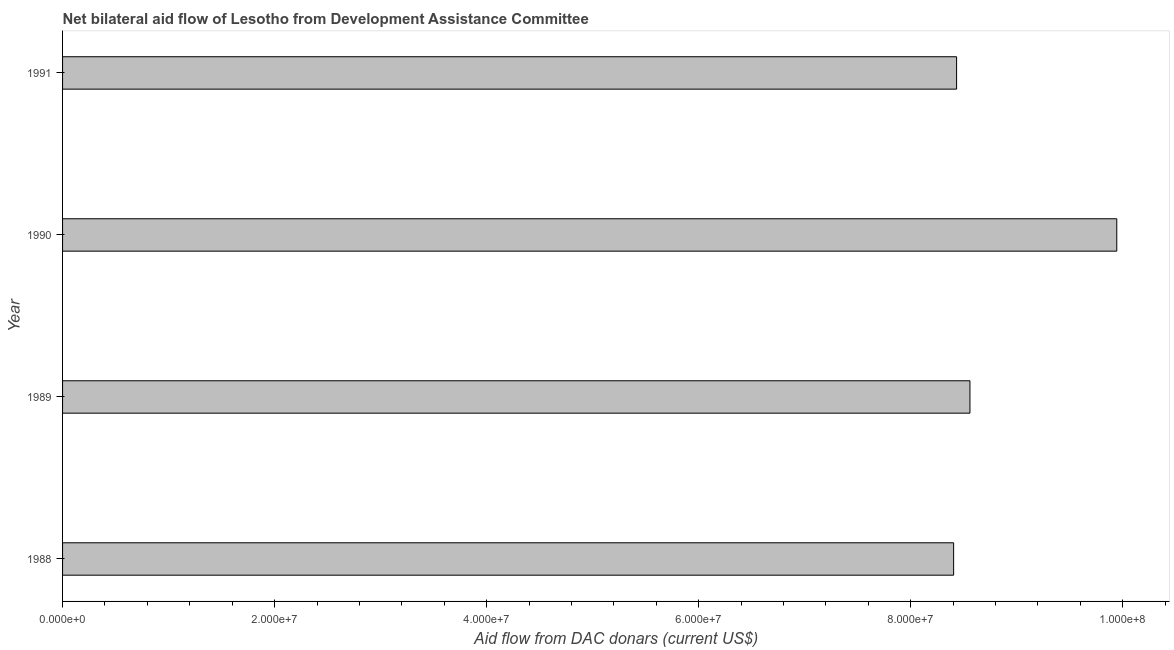Does the graph contain grids?
Your response must be concise. No. What is the title of the graph?
Your answer should be very brief. Net bilateral aid flow of Lesotho from Development Assistance Committee. What is the label or title of the X-axis?
Offer a terse response. Aid flow from DAC donars (current US$). What is the label or title of the Y-axis?
Provide a succinct answer. Year. What is the net bilateral aid flows from dac donors in 1988?
Give a very brief answer. 8.40e+07. Across all years, what is the maximum net bilateral aid flows from dac donors?
Provide a succinct answer. 9.94e+07. Across all years, what is the minimum net bilateral aid flows from dac donors?
Your response must be concise. 8.40e+07. In which year was the net bilateral aid flows from dac donors maximum?
Provide a short and direct response. 1990. What is the sum of the net bilateral aid flows from dac donors?
Your answer should be compact. 3.53e+08. What is the difference between the net bilateral aid flows from dac donors in 1989 and 1990?
Provide a short and direct response. -1.38e+07. What is the average net bilateral aid flows from dac donors per year?
Provide a short and direct response. 8.84e+07. What is the median net bilateral aid flows from dac donors?
Ensure brevity in your answer.  8.50e+07. Is the difference between the net bilateral aid flows from dac donors in 1989 and 1991 greater than the difference between any two years?
Your response must be concise. No. What is the difference between the highest and the second highest net bilateral aid flows from dac donors?
Offer a terse response. 1.38e+07. Is the sum of the net bilateral aid flows from dac donors in 1990 and 1991 greater than the maximum net bilateral aid flows from dac donors across all years?
Your response must be concise. Yes. What is the difference between the highest and the lowest net bilateral aid flows from dac donors?
Your response must be concise. 1.54e+07. In how many years, is the net bilateral aid flows from dac donors greater than the average net bilateral aid flows from dac donors taken over all years?
Provide a short and direct response. 1. How many bars are there?
Ensure brevity in your answer.  4. How many years are there in the graph?
Offer a terse response. 4. What is the Aid flow from DAC donars (current US$) of 1988?
Your answer should be very brief. 8.40e+07. What is the Aid flow from DAC donars (current US$) of 1989?
Provide a succinct answer. 8.56e+07. What is the Aid flow from DAC donars (current US$) in 1990?
Your answer should be compact. 9.94e+07. What is the Aid flow from DAC donars (current US$) in 1991?
Offer a very short reply. 8.43e+07. What is the difference between the Aid flow from DAC donars (current US$) in 1988 and 1989?
Ensure brevity in your answer.  -1.54e+06. What is the difference between the Aid flow from DAC donars (current US$) in 1988 and 1990?
Your answer should be compact. -1.54e+07. What is the difference between the Aid flow from DAC donars (current US$) in 1988 and 1991?
Give a very brief answer. -2.80e+05. What is the difference between the Aid flow from DAC donars (current US$) in 1989 and 1990?
Ensure brevity in your answer.  -1.38e+07. What is the difference between the Aid flow from DAC donars (current US$) in 1989 and 1991?
Your answer should be compact. 1.26e+06. What is the difference between the Aid flow from DAC donars (current US$) in 1990 and 1991?
Ensure brevity in your answer.  1.51e+07. What is the ratio of the Aid flow from DAC donars (current US$) in 1988 to that in 1989?
Your answer should be very brief. 0.98. What is the ratio of the Aid flow from DAC donars (current US$) in 1988 to that in 1990?
Provide a short and direct response. 0.84. What is the ratio of the Aid flow from DAC donars (current US$) in 1988 to that in 1991?
Ensure brevity in your answer.  1. What is the ratio of the Aid flow from DAC donars (current US$) in 1989 to that in 1990?
Keep it short and to the point. 0.86. What is the ratio of the Aid flow from DAC donars (current US$) in 1990 to that in 1991?
Ensure brevity in your answer.  1.18. 